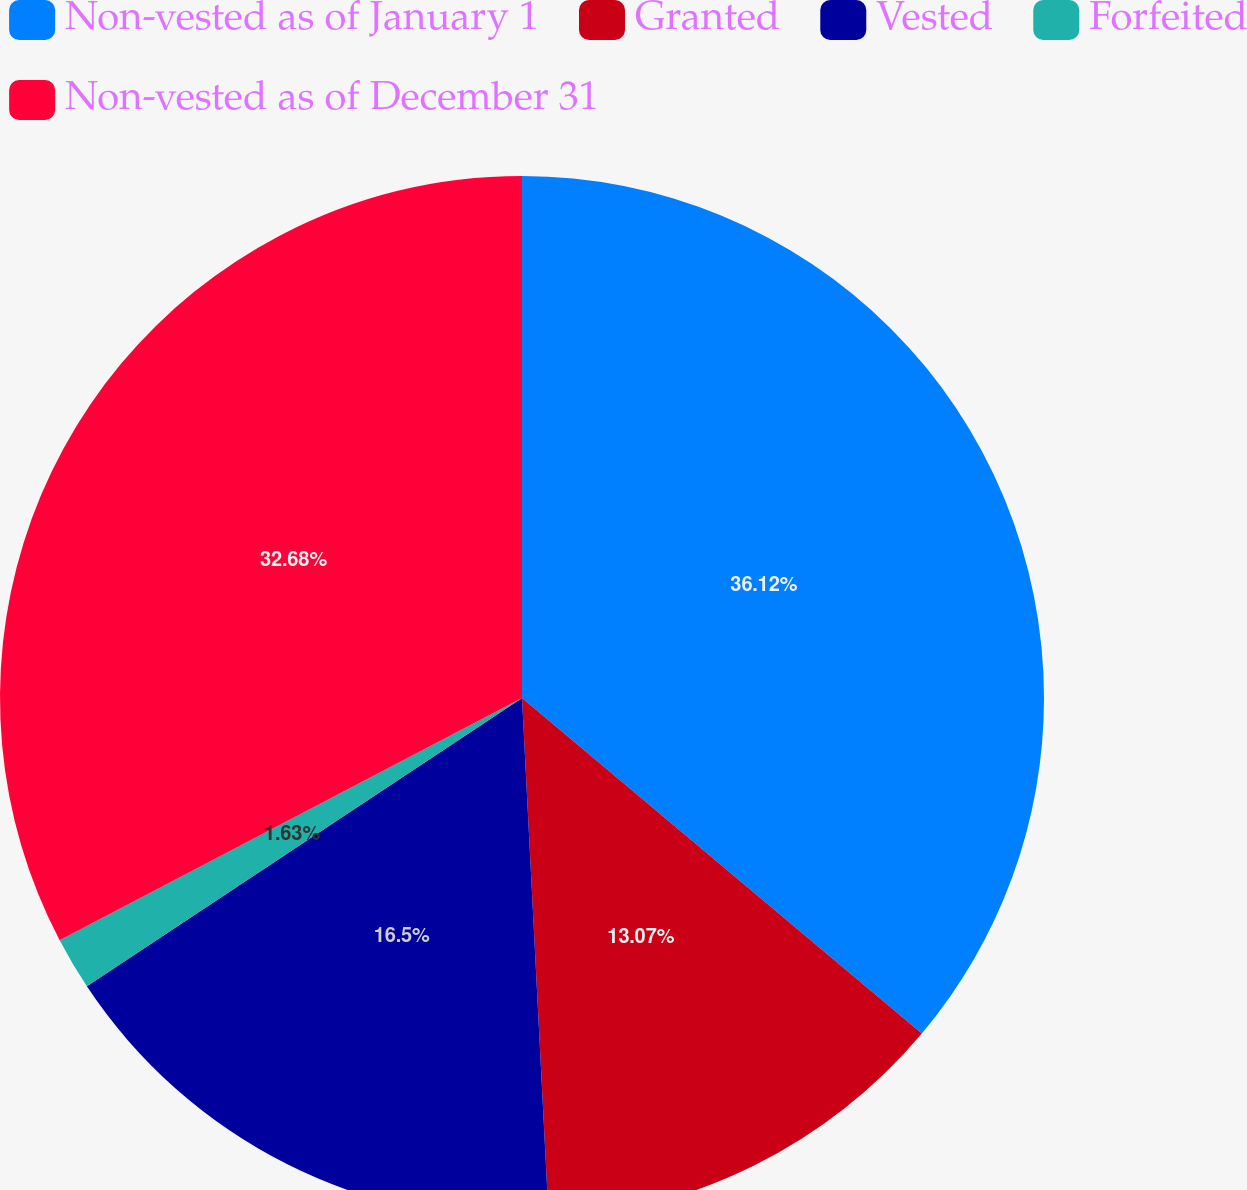<chart> <loc_0><loc_0><loc_500><loc_500><pie_chart><fcel>Non-vested as of January 1<fcel>Granted<fcel>Vested<fcel>Forfeited<fcel>Non-vested as of December 31<nl><fcel>36.11%<fcel>13.07%<fcel>16.5%<fcel>1.63%<fcel>32.68%<nl></chart> 